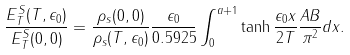Convert formula to latex. <formula><loc_0><loc_0><loc_500><loc_500>\frac { E _ { T } ^ { S } ( T , \epsilon _ { 0 } ) } { E _ { T } ^ { S } ( 0 , 0 ) } = \frac { \rho _ { s } ( 0 , 0 ) } { \rho _ { s } ( T , \epsilon _ { 0 } ) } \frac { \epsilon _ { 0 } } { 0 . 5 9 2 5 } \int _ { 0 } ^ { a + 1 } \tanh \frac { \epsilon _ { 0 } x } { 2 T } \frac { A B } { \pi ^ { 2 } } d x .</formula> 